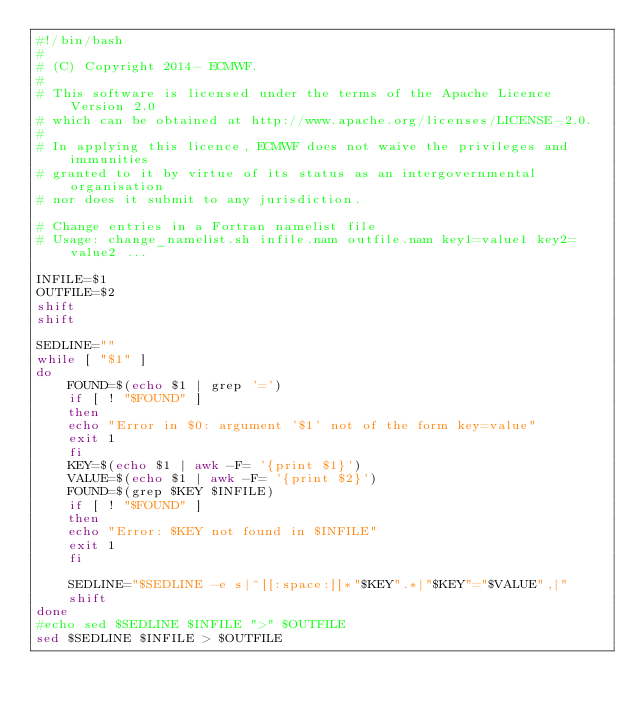Convert code to text. <code><loc_0><loc_0><loc_500><loc_500><_Bash_>#!/bin/bash
#
# (C) Copyright 2014- ECMWF.
#
# This software is licensed under the terms of the Apache Licence Version 2.0
# which can be obtained at http://www.apache.org/licenses/LICENSE-2.0.
#
# In applying this licence, ECMWF does not waive the privileges and immunities
# granted to it by virtue of its status as an intergovernmental organisation
# nor does it submit to any jurisdiction.

# Change entries in a Fortran namelist file
# Usage: change_namelist.sh infile.nam outfile.nam key1=value1 key2=value2 ...

INFILE=$1
OUTFILE=$2
shift
shift

SEDLINE=""
while [ "$1" ]
do
    FOUND=$(echo $1 | grep '=')
    if [ ! "$FOUND" ]
    then
	echo "Error in $0: argument '$1' not of the form key=value"
	exit 1
    fi
    KEY=$(echo $1 | awk -F= '{print $1}')
    VALUE=$(echo $1 | awk -F= '{print $2}')
    FOUND=$(grep $KEY $INFILE)
    if [ ! "$FOUND" ]
    then
	echo "Error: $KEY not found in $INFILE"
	exit 1
    fi

    SEDLINE="$SEDLINE -e s|^[[:space:]]*"$KEY".*|"$KEY"="$VALUE",|"
    shift
done
#echo sed $SEDLINE $INFILE ">" $OUTFILE
sed $SEDLINE $INFILE > $OUTFILE
</code> 